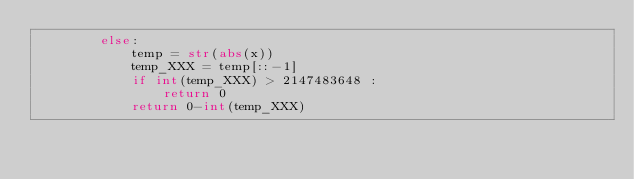Convert code to text. <code><loc_0><loc_0><loc_500><loc_500><_Python_>        else:
            temp = str(abs(x))
            temp_XXX = temp[::-1]
            if int(temp_XXX) > 2147483648 :
                return 0
            return 0-int(temp_XXX)

</code> 